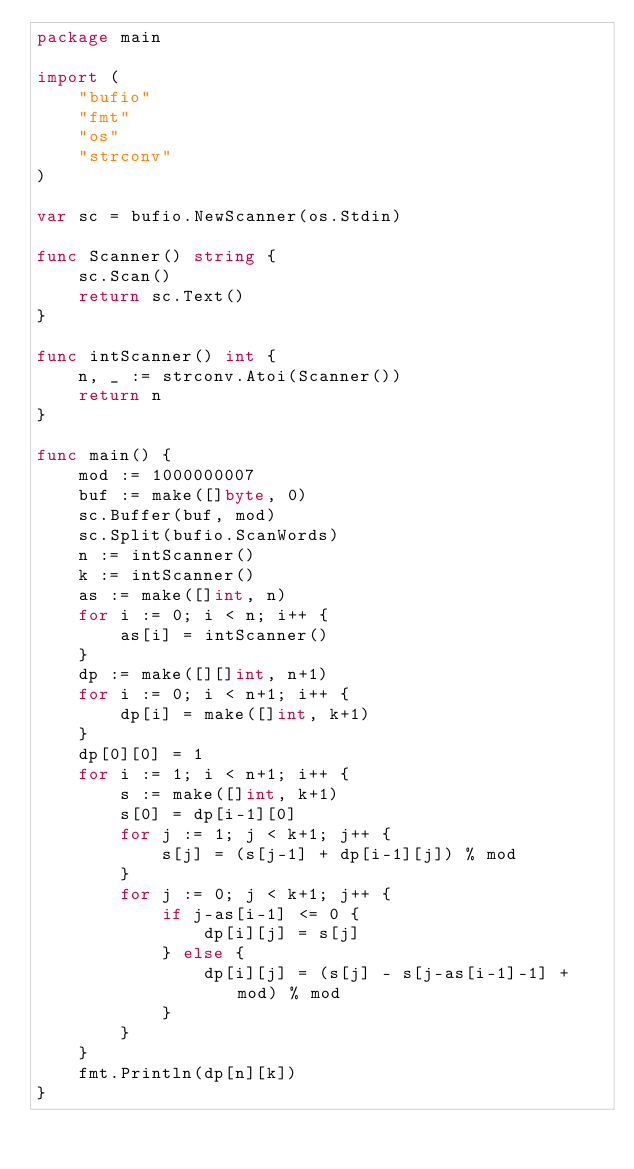<code> <loc_0><loc_0><loc_500><loc_500><_Go_>package main

import (
	"bufio"
	"fmt"
	"os"
	"strconv"
)

var sc = bufio.NewScanner(os.Stdin)

func Scanner() string {
	sc.Scan()
	return sc.Text()
}

func intScanner() int {
	n, _ := strconv.Atoi(Scanner())
	return n
}

func main() {
	mod := 1000000007
	buf := make([]byte, 0)
	sc.Buffer(buf, mod)
	sc.Split(bufio.ScanWords)
	n := intScanner()
	k := intScanner()
	as := make([]int, n)
	for i := 0; i < n; i++ {
		as[i] = intScanner()
	}
	dp := make([][]int, n+1)
	for i := 0; i < n+1; i++ {
		dp[i] = make([]int, k+1)
	}
	dp[0][0] = 1
	for i := 1; i < n+1; i++ {
		s := make([]int, k+1)
		s[0] = dp[i-1][0]
		for j := 1; j < k+1; j++ {
			s[j] = (s[j-1] + dp[i-1][j]) % mod
		}
		for j := 0; j < k+1; j++ {
			if j-as[i-1] <= 0 {
				dp[i][j] = s[j]
			} else {
				dp[i][j] = (s[j] - s[j-as[i-1]-1] + mod) % mod
			}
		}
	}
	fmt.Println(dp[n][k])
}
</code> 